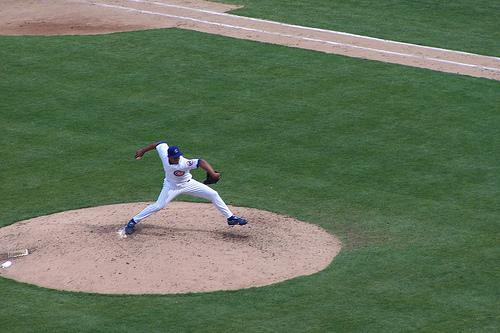Question: what sport is being played?
Choices:
A. Tennis.
B. Football.
C. Soccer.
D. Baseball.
Answer with the letter. Answer: D Question: who is wearing a hat?
Choices:
A. The tennis player.
B. The pitcher.
C. The man at the left.
D. The elegant woman in the middle.
Answer with the letter. Answer: B Question: what type of field is this?
Choices:
A. A soccer field.
B. A baseball field.
C. A football field.
D. A rugby field.
Answer with the letter. Answer: B Question: what is the player doing?
Choices:
A. Pitching the ball.
B. Serving.
C. Catching the ball.
D. Running.
Answer with the letter. Answer: A 